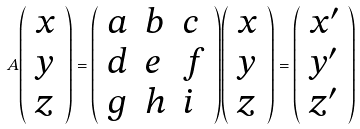Convert formula to latex. <formula><loc_0><loc_0><loc_500><loc_500>A { \left ( \begin{array} { l } { x } \\ { y } \\ { z } \end{array} \right ) } = { \left ( \begin{array} { l l l } { a } & { b } & { c } \\ { d } & { e } & { f } \\ { g } & { h } & { i } \end{array} \right ) } { \left ( \begin{array} { l } { x } \\ { y } \\ { z } \end{array} \right ) } = { \left ( \begin{array} { l } { x ^ { \prime } } \\ { y ^ { \prime } } \\ { z ^ { \prime } } \end{array} \right ) }</formula> 